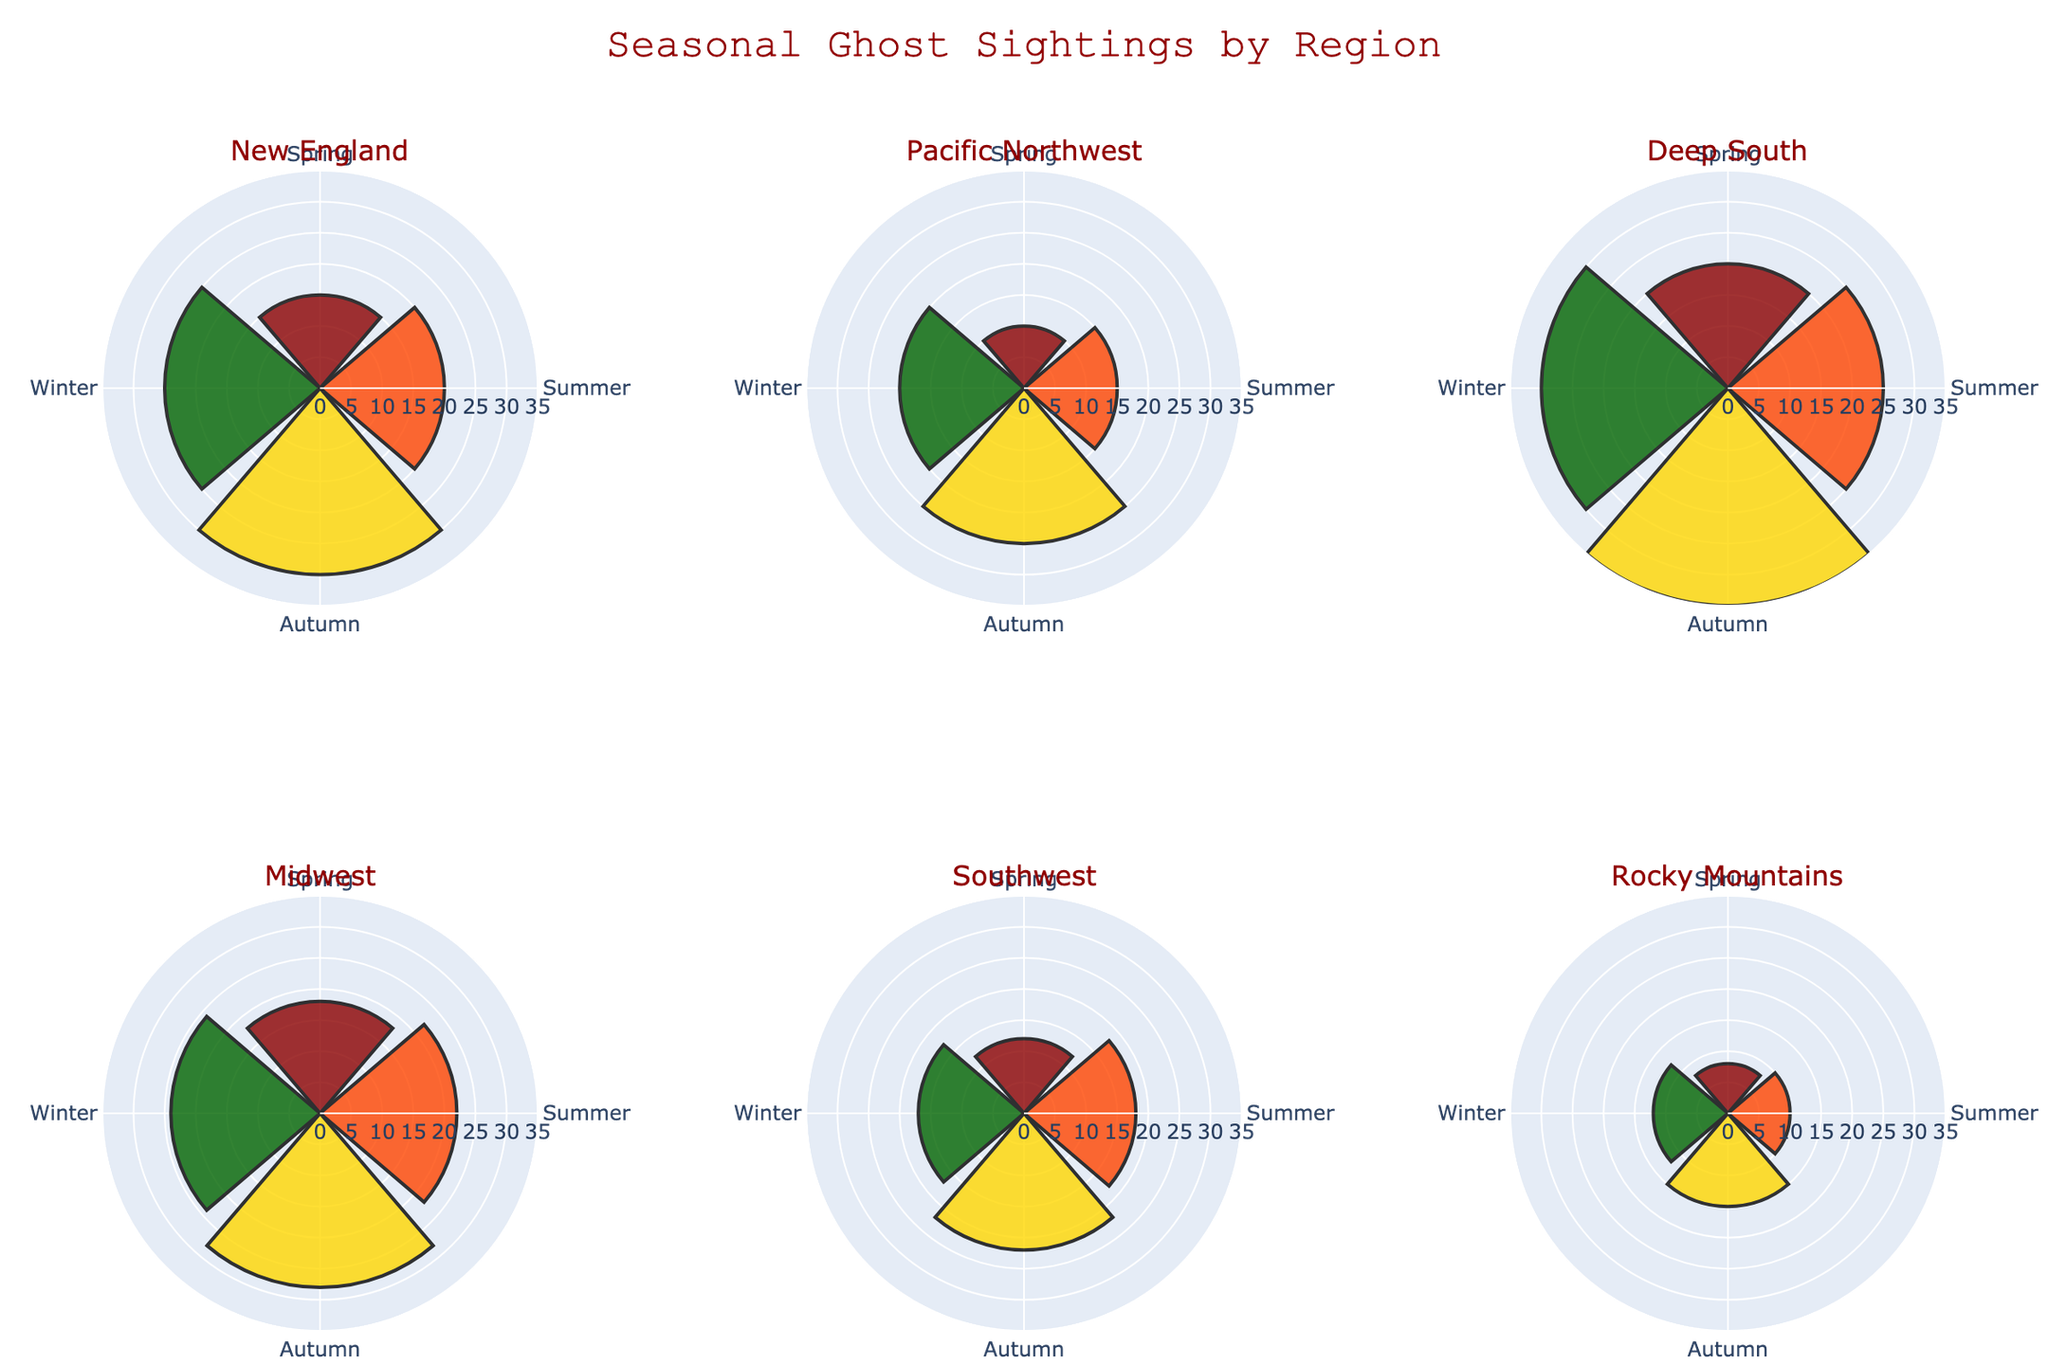What is the title of the figure? The title of the figure is placed at the top and reads "Seasonal Ghost Sightings by Region."
Answer: Seasonal Ghost Sightings by Region Which region reports the highest number of ghost sightings in Autumn? By looking at the rose charts, we can see that the Deep South has the largest segment in Autumn. This indicates the highest number of ghost sightings for this season.
Answer: Deep South Which season has the least ghost sightings in the Rocky Mountains? Observing the rose chart for the Rocky Mountains, the Spring segment is the smallest, indicating it has the least number of ghost sightings.
Answer: Spring How many seasons are represented in the rose chart for each region? Each region's rose chart has four segments representing Spring, Summer, Autumn, and Winter.
Answer: 4 What is the total number of ghost sightings reported in New England across all seasons? Summing up the number of ghost sightings in New England: Spring (15), Summer (20), Autumn (30), Winter (25). The total is 15 + 20 + 30 + 25 = 90.
Answer: 90 Which region has the most balanced distribution of ghost sightings across all seasons? By examining the consistency in segment sizes across all seasons within each rose chart, the Midwest appears to have relatively balanced segments compared to other regions.
Answer: Midwest Compare the number of ghost sightings in the Winter between the Pacific Northwest and the Southwest. Which one is higher? The Pacific Northwest reports 20 sightings in Winter, while the Southwest reports 17 sightings. Since 20 > 17, the Pacific Northwest has a higher number of sightings in Winter.
Answer: Pacific Northwest In which season does the Southwest report the most ghost sightings? Observing the rose chart for the Southwest, the Summer segment is the largest, indicating the most ghost sightings in that season.
Answer: Summer What is the average number of ghost sightings in the Deep South during Spring and Autumn? To find the average, sum the sightings in Spring (20) and Autumn (35), then divide by 2. (20 + 35)/2 = 55/2 = 27.5.
Answer: 27.5 Which two regions show the least number of ghost sightings in Summer? By examining the rose charts, we notice that the Rocky Mountains (10 sightings) and the Pacific Northwest (15 sightings) have the smallest segments in Summer.
Answer: Rocky Mountains, Pacific Northwest 